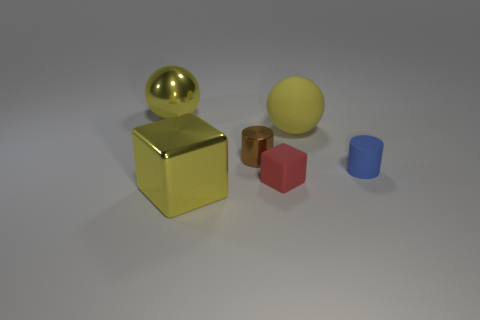Add 2 large metal spheres. How many objects exist? 8 Subtract all cylinders. How many objects are left? 4 Add 2 small shiny cylinders. How many small shiny cylinders are left? 3 Add 5 big yellow shiny balls. How many big yellow shiny balls exist? 6 Subtract 0 red cylinders. How many objects are left? 6 Subtract all large gray cubes. Subtract all small red objects. How many objects are left? 5 